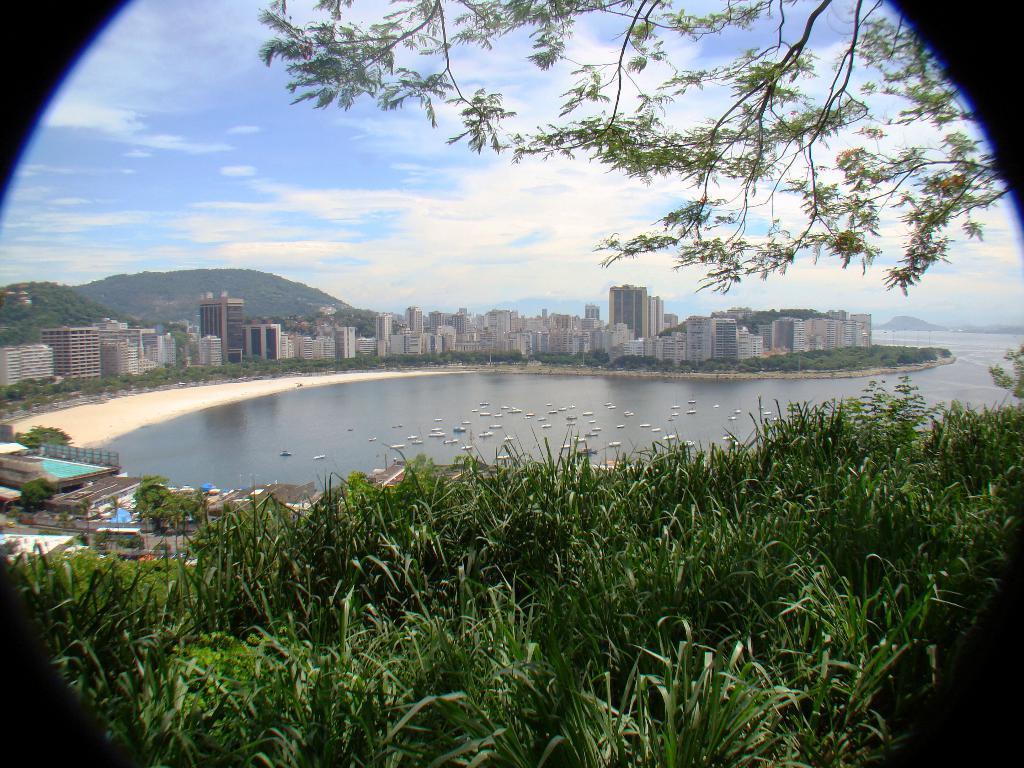Describe this image in one or two sentences. In this picture we can observe some grass on the ground. There is an ocean. We can observe some boats on the water. There are buildings. In the background there are hills and a sky with clouds. 